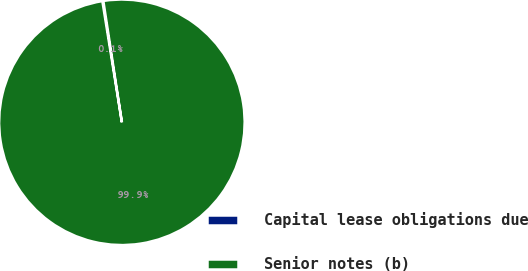Convert chart to OTSL. <chart><loc_0><loc_0><loc_500><loc_500><pie_chart><fcel>Capital lease obligations due<fcel>Senior notes (b)<nl><fcel>0.13%<fcel>99.87%<nl></chart> 